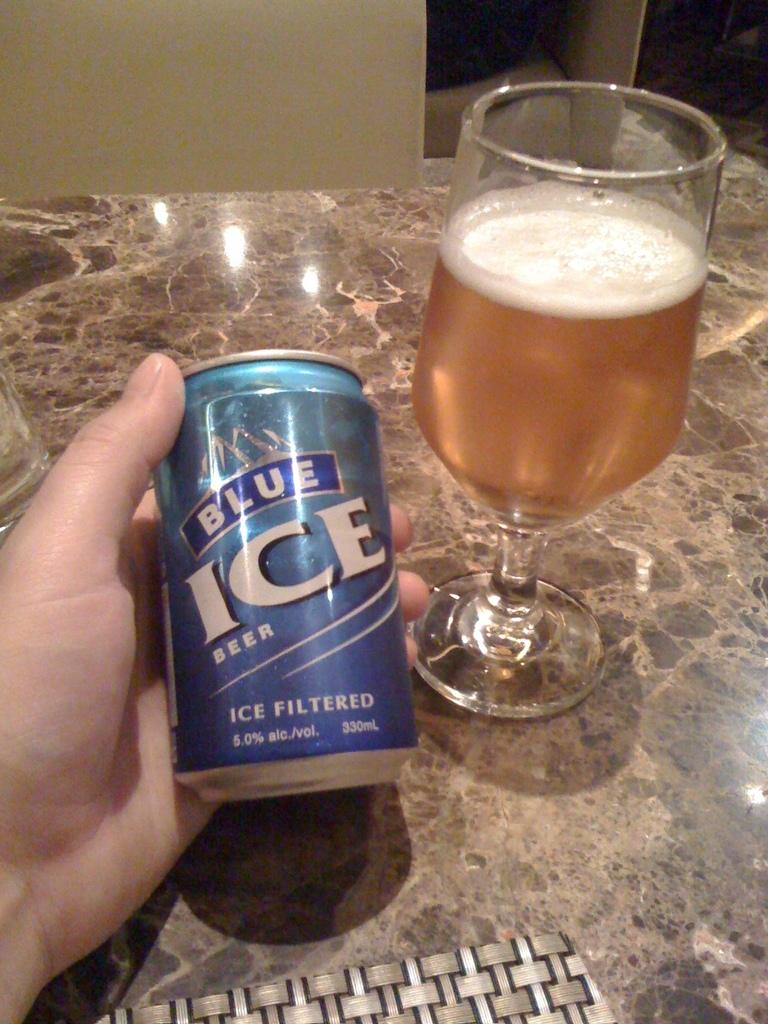Provide a one-sentence caption for the provided image. A person holding a can of Blue Ice Beer with a goblet of beer that is partially drank. 